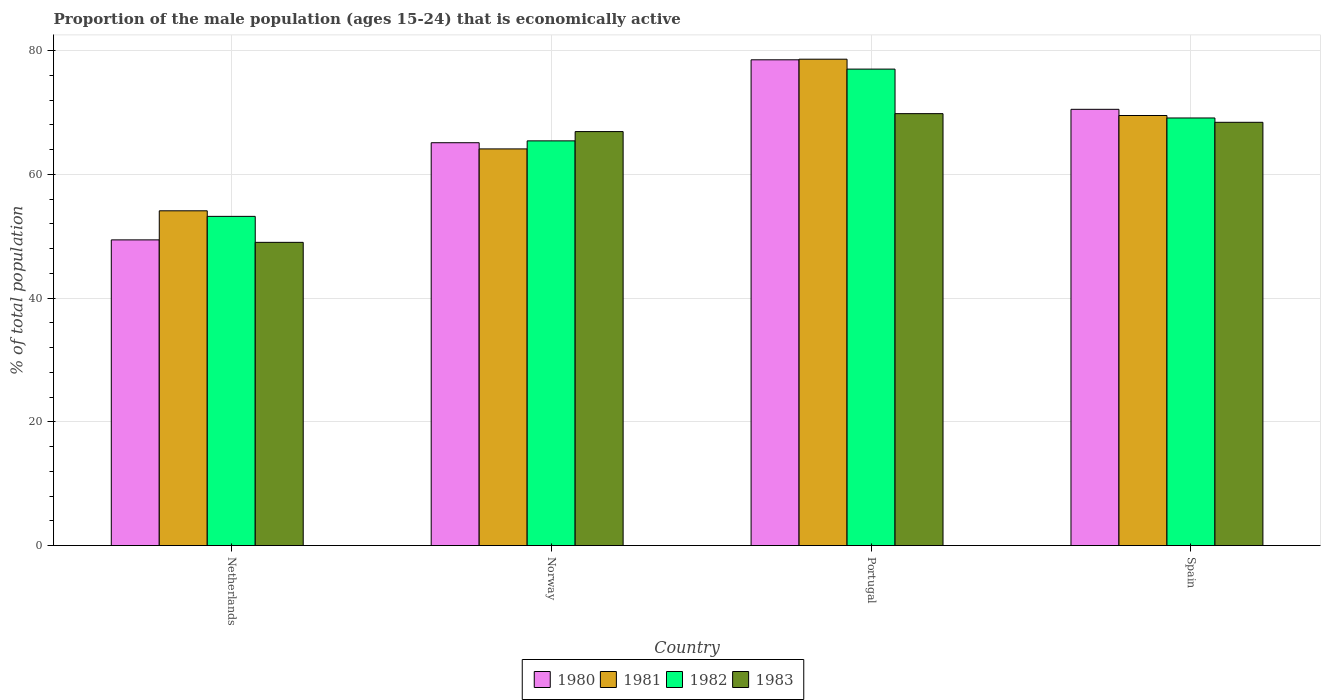Are the number of bars per tick equal to the number of legend labels?
Your answer should be very brief. Yes. How many bars are there on the 3rd tick from the right?
Give a very brief answer. 4. What is the proportion of the male population that is economically active in 1983 in Norway?
Ensure brevity in your answer.  66.9. Across all countries, what is the maximum proportion of the male population that is economically active in 1980?
Keep it short and to the point. 78.5. Across all countries, what is the minimum proportion of the male population that is economically active in 1983?
Provide a succinct answer. 49. In which country was the proportion of the male population that is economically active in 1980 minimum?
Offer a very short reply. Netherlands. What is the total proportion of the male population that is economically active in 1980 in the graph?
Your response must be concise. 263.5. What is the difference between the proportion of the male population that is economically active in 1981 in Spain and the proportion of the male population that is economically active in 1983 in Norway?
Make the answer very short. 2.6. What is the average proportion of the male population that is economically active in 1981 per country?
Your response must be concise. 66.57. What is the difference between the proportion of the male population that is economically active of/in 1980 and proportion of the male population that is economically active of/in 1981 in Portugal?
Your response must be concise. -0.1. In how many countries, is the proportion of the male population that is economically active in 1982 greater than 24 %?
Keep it short and to the point. 4. What is the ratio of the proportion of the male population that is economically active in 1982 in Netherlands to that in Norway?
Keep it short and to the point. 0.81. Is the difference between the proportion of the male population that is economically active in 1980 in Netherlands and Portugal greater than the difference between the proportion of the male population that is economically active in 1981 in Netherlands and Portugal?
Provide a succinct answer. No. What is the difference between the highest and the second highest proportion of the male population that is economically active in 1980?
Give a very brief answer. -5.4. What is the difference between the highest and the lowest proportion of the male population that is economically active in 1981?
Your response must be concise. 24.5. Is it the case that in every country, the sum of the proportion of the male population that is economically active in 1980 and proportion of the male population that is economically active in 1982 is greater than the sum of proportion of the male population that is economically active in 1983 and proportion of the male population that is economically active in 1981?
Ensure brevity in your answer.  No. What does the 1st bar from the left in Norway represents?
Provide a succinct answer. 1980. Are all the bars in the graph horizontal?
Your answer should be very brief. No. How many countries are there in the graph?
Make the answer very short. 4. Are the values on the major ticks of Y-axis written in scientific E-notation?
Your answer should be compact. No. Where does the legend appear in the graph?
Provide a succinct answer. Bottom center. How many legend labels are there?
Keep it short and to the point. 4. How are the legend labels stacked?
Provide a succinct answer. Horizontal. What is the title of the graph?
Ensure brevity in your answer.  Proportion of the male population (ages 15-24) that is economically active. Does "1962" appear as one of the legend labels in the graph?
Make the answer very short. No. What is the label or title of the X-axis?
Offer a very short reply. Country. What is the label or title of the Y-axis?
Your answer should be very brief. % of total population. What is the % of total population of 1980 in Netherlands?
Provide a short and direct response. 49.4. What is the % of total population in 1981 in Netherlands?
Your answer should be very brief. 54.1. What is the % of total population in 1982 in Netherlands?
Keep it short and to the point. 53.2. What is the % of total population of 1980 in Norway?
Your answer should be compact. 65.1. What is the % of total population of 1981 in Norway?
Provide a succinct answer. 64.1. What is the % of total population in 1982 in Norway?
Ensure brevity in your answer.  65.4. What is the % of total population of 1983 in Norway?
Ensure brevity in your answer.  66.9. What is the % of total population of 1980 in Portugal?
Make the answer very short. 78.5. What is the % of total population of 1981 in Portugal?
Offer a very short reply. 78.6. What is the % of total population in 1983 in Portugal?
Offer a terse response. 69.8. What is the % of total population of 1980 in Spain?
Keep it short and to the point. 70.5. What is the % of total population in 1981 in Spain?
Your response must be concise. 69.5. What is the % of total population of 1982 in Spain?
Provide a short and direct response. 69.1. What is the % of total population of 1983 in Spain?
Give a very brief answer. 68.4. Across all countries, what is the maximum % of total population in 1980?
Provide a succinct answer. 78.5. Across all countries, what is the maximum % of total population of 1981?
Make the answer very short. 78.6. Across all countries, what is the maximum % of total population of 1983?
Keep it short and to the point. 69.8. Across all countries, what is the minimum % of total population in 1980?
Offer a very short reply. 49.4. Across all countries, what is the minimum % of total population in 1981?
Offer a terse response. 54.1. Across all countries, what is the minimum % of total population of 1982?
Make the answer very short. 53.2. What is the total % of total population in 1980 in the graph?
Your response must be concise. 263.5. What is the total % of total population of 1981 in the graph?
Make the answer very short. 266.3. What is the total % of total population of 1982 in the graph?
Ensure brevity in your answer.  264.7. What is the total % of total population in 1983 in the graph?
Offer a terse response. 254.1. What is the difference between the % of total population of 1980 in Netherlands and that in Norway?
Offer a terse response. -15.7. What is the difference between the % of total population of 1982 in Netherlands and that in Norway?
Your answer should be compact. -12.2. What is the difference between the % of total population of 1983 in Netherlands and that in Norway?
Offer a very short reply. -17.9. What is the difference between the % of total population of 1980 in Netherlands and that in Portugal?
Ensure brevity in your answer.  -29.1. What is the difference between the % of total population in 1981 in Netherlands and that in Portugal?
Provide a short and direct response. -24.5. What is the difference between the % of total population of 1982 in Netherlands and that in Portugal?
Offer a terse response. -23.8. What is the difference between the % of total population of 1983 in Netherlands and that in Portugal?
Your answer should be compact. -20.8. What is the difference between the % of total population of 1980 in Netherlands and that in Spain?
Make the answer very short. -21.1. What is the difference between the % of total population of 1981 in Netherlands and that in Spain?
Keep it short and to the point. -15.4. What is the difference between the % of total population of 1982 in Netherlands and that in Spain?
Your response must be concise. -15.9. What is the difference between the % of total population of 1983 in Netherlands and that in Spain?
Make the answer very short. -19.4. What is the difference between the % of total population of 1980 in Norway and that in Portugal?
Offer a very short reply. -13.4. What is the difference between the % of total population of 1981 in Norway and that in Portugal?
Your answer should be very brief. -14.5. What is the difference between the % of total population in 1981 in Norway and that in Spain?
Ensure brevity in your answer.  -5.4. What is the difference between the % of total population in 1983 in Norway and that in Spain?
Give a very brief answer. -1.5. What is the difference between the % of total population of 1982 in Portugal and that in Spain?
Give a very brief answer. 7.9. What is the difference between the % of total population of 1983 in Portugal and that in Spain?
Your answer should be compact. 1.4. What is the difference between the % of total population of 1980 in Netherlands and the % of total population of 1981 in Norway?
Ensure brevity in your answer.  -14.7. What is the difference between the % of total population in 1980 in Netherlands and the % of total population in 1983 in Norway?
Give a very brief answer. -17.5. What is the difference between the % of total population of 1981 in Netherlands and the % of total population of 1983 in Norway?
Ensure brevity in your answer.  -12.8. What is the difference between the % of total population of 1982 in Netherlands and the % of total population of 1983 in Norway?
Make the answer very short. -13.7. What is the difference between the % of total population in 1980 in Netherlands and the % of total population in 1981 in Portugal?
Provide a short and direct response. -29.2. What is the difference between the % of total population in 1980 in Netherlands and the % of total population in 1982 in Portugal?
Your answer should be very brief. -27.6. What is the difference between the % of total population in 1980 in Netherlands and the % of total population in 1983 in Portugal?
Keep it short and to the point. -20.4. What is the difference between the % of total population of 1981 in Netherlands and the % of total population of 1982 in Portugal?
Keep it short and to the point. -22.9. What is the difference between the % of total population of 1981 in Netherlands and the % of total population of 1983 in Portugal?
Offer a very short reply. -15.7. What is the difference between the % of total population in 1982 in Netherlands and the % of total population in 1983 in Portugal?
Make the answer very short. -16.6. What is the difference between the % of total population of 1980 in Netherlands and the % of total population of 1981 in Spain?
Give a very brief answer. -20.1. What is the difference between the % of total population of 1980 in Netherlands and the % of total population of 1982 in Spain?
Your answer should be compact. -19.7. What is the difference between the % of total population of 1980 in Netherlands and the % of total population of 1983 in Spain?
Your answer should be very brief. -19. What is the difference between the % of total population of 1981 in Netherlands and the % of total population of 1982 in Spain?
Your answer should be very brief. -15. What is the difference between the % of total population of 1981 in Netherlands and the % of total population of 1983 in Spain?
Provide a succinct answer. -14.3. What is the difference between the % of total population of 1982 in Netherlands and the % of total population of 1983 in Spain?
Make the answer very short. -15.2. What is the difference between the % of total population in 1980 in Norway and the % of total population in 1981 in Portugal?
Your answer should be very brief. -13.5. What is the difference between the % of total population of 1980 in Norway and the % of total population of 1982 in Portugal?
Provide a short and direct response. -11.9. What is the difference between the % of total population of 1982 in Norway and the % of total population of 1983 in Portugal?
Provide a succinct answer. -4.4. What is the difference between the % of total population of 1980 in Portugal and the % of total population of 1981 in Spain?
Offer a very short reply. 9. What is the difference between the % of total population in 1980 in Portugal and the % of total population in 1982 in Spain?
Your answer should be compact. 9.4. What is the difference between the % of total population of 1980 in Portugal and the % of total population of 1983 in Spain?
Provide a succinct answer. 10.1. What is the difference between the % of total population in 1982 in Portugal and the % of total population in 1983 in Spain?
Offer a very short reply. 8.6. What is the average % of total population in 1980 per country?
Ensure brevity in your answer.  65.88. What is the average % of total population in 1981 per country?
Your response must be concise. 66.58. What is the average % of total population in 1982 per country?
Offer a terse response. 66.17. What is the average % of total population of 1983 per country?
Offer a terse response. 63.52. What is the difference between the % of total population of 1980 and % of total population of 1981 in Netherlands?
Your response must be concise. -4.7. What is the difference between the % of total population in 1980 and % of total population in 1982 in Netherlands?
Offer a very short reply. -3.8. What is the difference between the % of total population of 1981 and % of total population of 1982 in Netherlands?
Offer a terse response. 0.9. What is the difference between the % of total population of 1981 and % of total population of 1982 in Norway?
Offer a very short reply. -1.3. What is the difference between the % of total population of 1981 and % of total population of 1983 in Portugal?
Give a very brief answer. 8.8. What is the difference between the % of total population in 1980 and % of total population in 1982 in Spain?
Provide a succinct answer. 1.4. What is the difference between the % of total population in 1981 and % of total population in 1982 in Spain?
Offer a very short reply. 0.4. What is the ratio of the % of total population in 1980 in Netherlands to that in Norway?
Your response must be concise. 0.76. What is the ratio of the % of total population of 1981 in Netherlands to that in Norway?
Keep it short and to the point. 0.84. What is the ratio of the % of total population in 1982 in Netherlands to that in Norway?
Keep it short and to the point. 0.81. What is the ratio of the % of total population in 1983 in Netherlands to that in Norway?
Your response must be concise. 0.73. What is the ratio of the % of total population of 1980 in Netherlands to that in Portugal?
Your answer should be compact. 0.63. What is the ratio of the % of total population of 1981 in Netherlands to that in Portugal?
Ensure brevity in your answer.  0.69. What is the ratio of the % of total population in 1982 in Netherlands to that in Portugal?
Give a very brief answer. 0.69. What is the ratio of the % of total population of 1983 in Netherlands to that in Portugal?
Provide a succinct answer. 0.7. What is the ratio of the % of total population of 1980 in Netherlands to that in Spain?
Keep it short and to the point. 0.7. What is the ratio of the % of total population in 1981 in Netherlands to that in Spain?
Give a very brief answer. 0.78. What is the ratio of the % of total population of 1982 in Netherlands to that in Spain?
Your answer should be very brief. 0.77. What is the ratio of the % of total population of 1983 in Netherlands to that in Spain?
Make the answer very short. 0.72. What is the ratio of the % of total population of 1980 in Norway to that in Portugal?
Your answer should be very brief. 0.83. What is the ratio of the % of total population of 1981 in Norway to that in Portugal?
Provide a short and direct response. 0.82. What is the ratio of the % of total population of 1982 in Norway to that in Portugal?
Your answer should be very brief. 0.85. What is the ratio of the % of total population in 1983 in Norway to that in Portugal?
Ensure brevity in your answer.  0.96. What is the ratio of the % of total population of 1980 in Norway to that in Spain?
Give a very brief answer. 0.92. What is the ratio of the % of total population in 1981 in Norway to that in Spain?
Your answer should be compact. 0.92. What is the ratio of the % of total population of 1982 in Norway to that in Spain?
Your answer should be compact. 0.95. What is the ratio of the % of total population in 1983 in Norway to that in Spain?
Your response must be concise. 0.98. What is the ratio of the % of total population in 1980 in Portugal to that in Spain?
Make the answer very short. 1.11. What is the ratio of the % of total population in 1981 in Portugal to that in Spain?
Ensure brevity in your answer.  1.13. What is the ratio of the % of total population of 1982 in Portugal to that in Spain?
Your answer should be compact. 1.11. What is the ratio of the % of total population of 1983 in Portugal to that in Spain?
Offer a very short reply. 1.02. What is the difference between the highest and the second highest % of total population of 1983?
Your answer should be very brief. 1.4. What is the difference between the highest and the lowest % of total population of 1980?
Keep it short and to the point. 29.1. What is the difference between the highest and the lowest % of total population in 1982?
Give a very brief answer. 23.8. What is the difference between the highest and the lowest % of total population of 1983?
Provide a succinct answer. 20.8. 